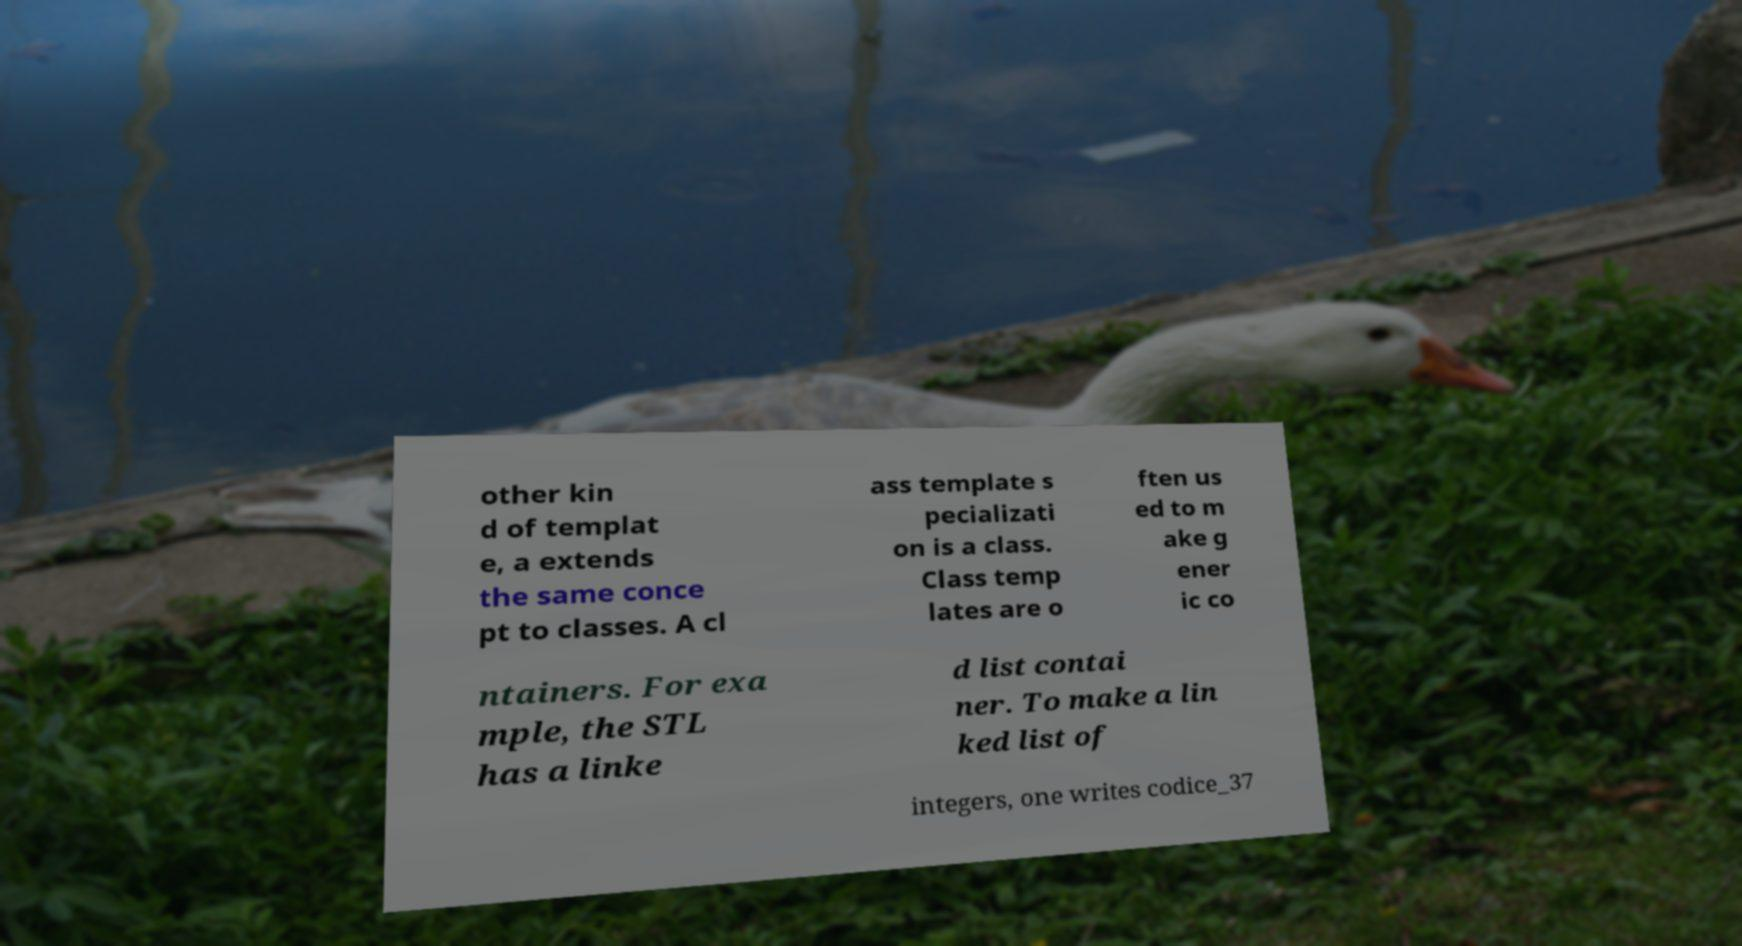Could you extract and type out the text from this image? other kin d of templat e, a extends the same conce pt to classes. A cl ass template s pecializati on is a class. Class temp lates are o ften us ed to m ake g ener ic co ntainers. For exa mple, the STL has a linke d list contai ner. To make a lin ked list of integers, one writes codice_37 